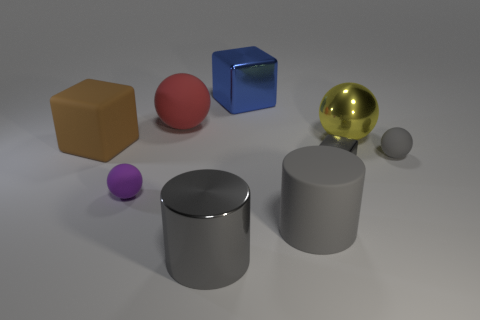Add 1 small metal objects. How many objects exist? 10 Subtract all balls. How many objects are left? 5 Add 1 purple metal cubes. How many purple metal cubes exist? 1 Subtract 0 red cylinders. How many objects are left? 9 Subtract all yellow shiny things. Subtract all blue objects. How many objects are left? 7 Add 2 gray things. How many gray things are left? 6 